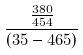Convert formula to latex. <formula><loc_0><loc_0><loc_500><loc_500>\frac { \frac { 3 8 0 } { 4 5 4 } } { ( 3 5 - 4 6 5 ) }</formula> 